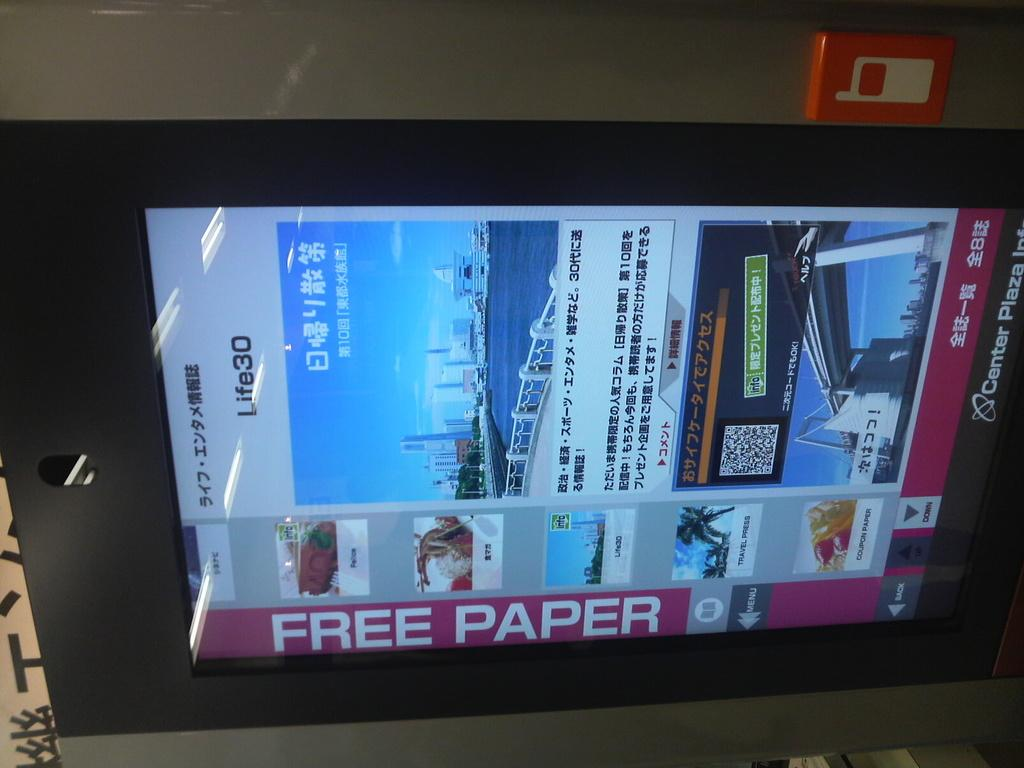<image>
Describe the image concisely. A promotional display screen indicates the opportunity for free paper along with images and words in another language. 